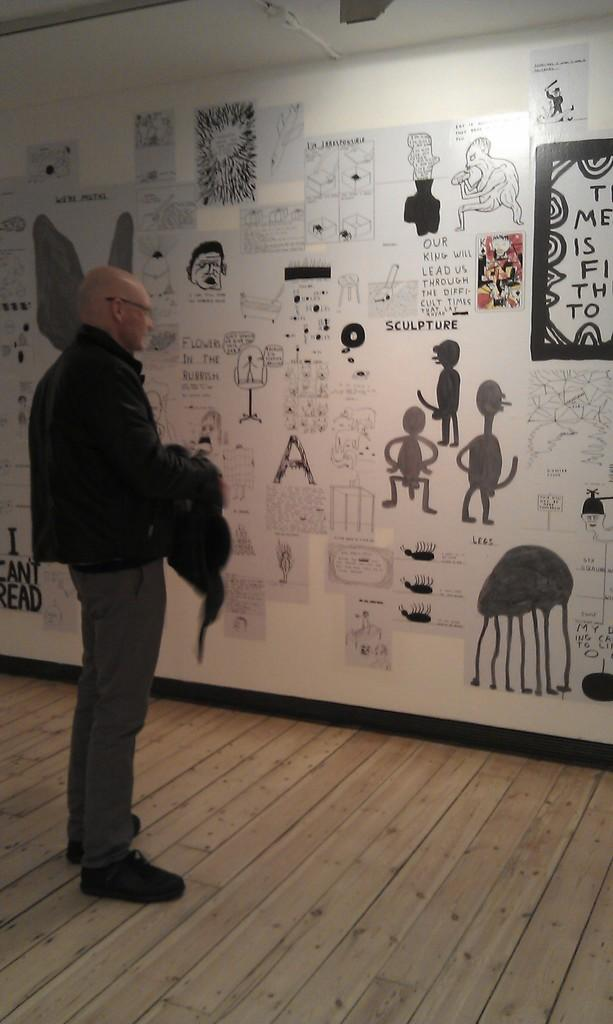What is the appearance of the man in the image? The man in the image is bald-headed. What is the man wearing in the image? The man is wearing a black dress. What type of floor is the man standing on? The man is standing on a wooden floor. What is the man looking at in the image? The man is staring at a wall. What can be seen on the wall in the image? The wall has many paintings on it. What type of pet is sitting next to the man in the image? There is no pet present in the image. What record is the man holding in his hand in the image? The man is not holding any record in the image. Is there a flame visible on the wall in the image? No, there is no flame visible on the wall in the image. 